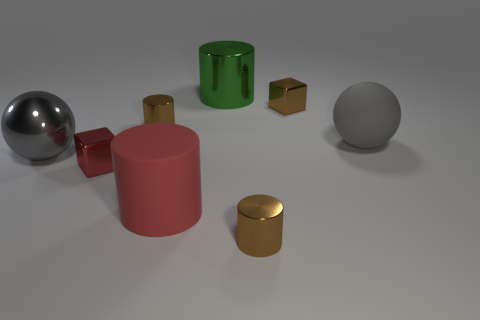Subtract all green cylinders. How many cylinders are left? 3 Add 1 small metal objects. How many objects exist? 9 Subtract all blue cylinders. Subtract all brown blocks. How many cylinders are left? 4 Subtract all balls. How many objects are left? 6 Subtract 0 yellow blocks. How many objects are left? 8 Subtract all large red cylinders. Subtract all small brown objects. How many objects are left? 4 Add 4 large rubber things. How many large rubber things are left? 6 Add 7 big metallic cylinders. How many big metallic cylinders exist? 8 